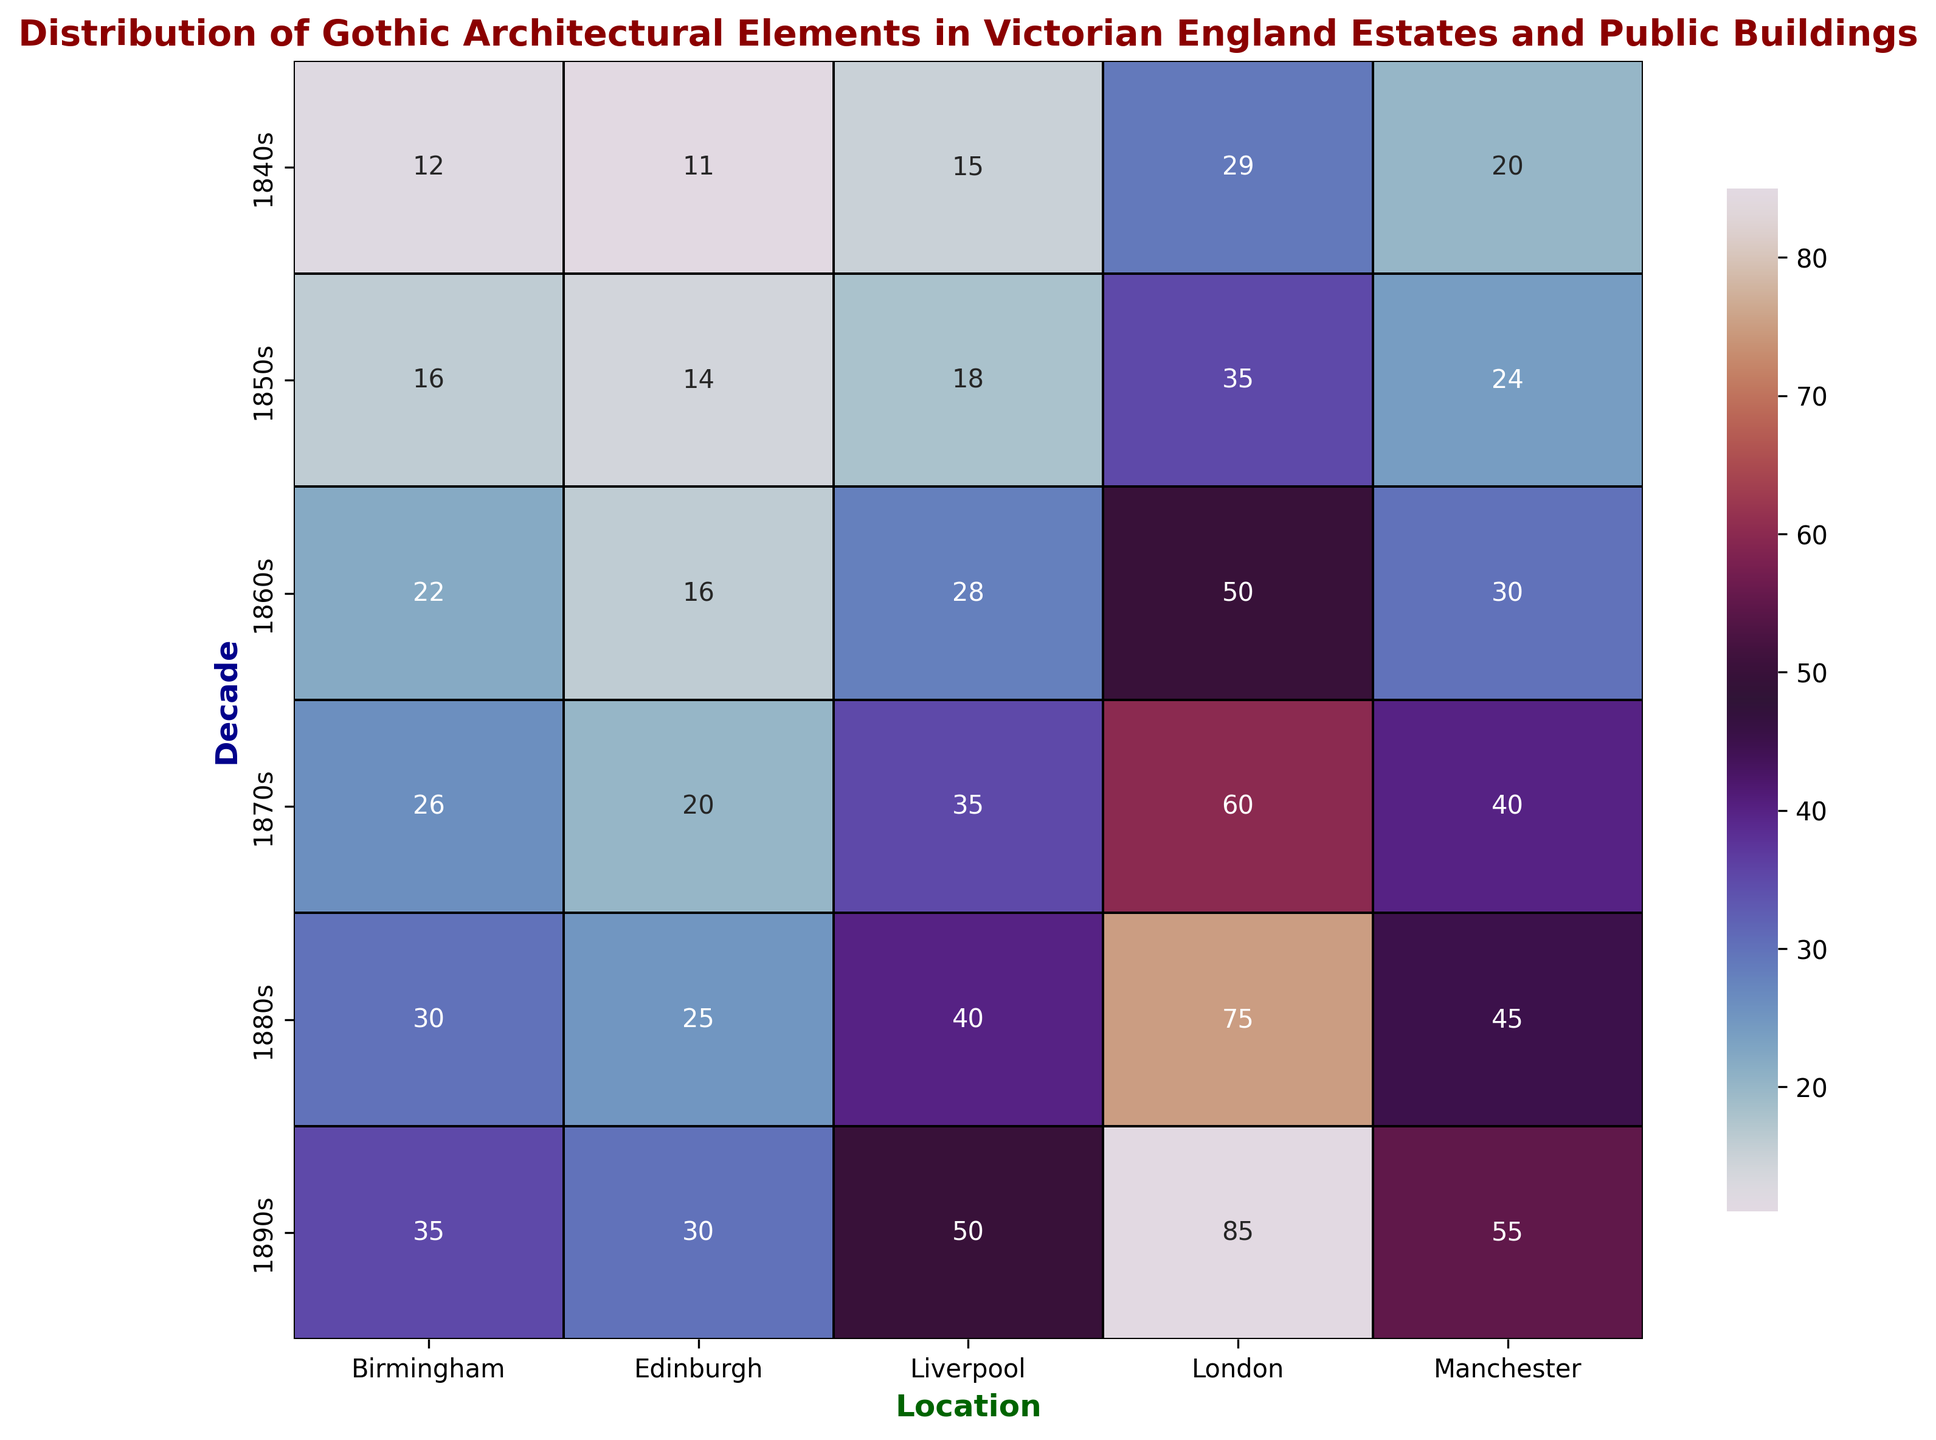What is the location with the highest number of Gothic architectural elements in the 1860s? To find the answer, look at the 1860s row and compare the numbers in each location column. London has the highest value in that decade with 50 elements.
Answer: London Which decade shows the greatest overall increase in Gothic architectural elements in London? Examine the figures for London across the decades. The increase is calculated by subtracting the previous decade's number from the current decade's number. The increase from the 1880s to the 1890s is the largest (85 - 75 = 10).
Answer: 1890s How many more Gothic architectural elements are there in Manchester compared to Edinburgh in the 1880s? Locate the numbers for Manchester and Edinburgh in the 1880s row. Subtract Edinburgh's number (25) from Manchester's number (45). 45 - 25 = 20.
Answer: 20 What is the average number of Gothic architectural elements in Birmingham across all decades? Add the values for Birmingham across all decades: 12 + 16 + 22 + 26 + 30 + 35 = 141. Divide by the number of decades (6). 141 / 6 = 23.5.
Answer: 23.5 Which location has the lowest number of Gothic architectural elements in the 1840s and how many are there? Look at the 1840s row and find the lowest value, which is 11 for Edinburgh.
Answer: Edinburgh, 11 How do the number of Gothic architectural elements in the 1850s in Liverpool compare to those in Edinburgh in the same decade? Locate the values for Liverpool (18) and Edinburgh (14) in the 1850s row. Liverpool has more elements.
Answer: Liverpool has more Which two locations have the same number of Gothic architectural elements in any decade? Locate identical values in the same row across the locations columns. In the 1840s, Manchester has 20, and no other location has the same value. Continue to the next row. In the 1850s, the values are unique to each location. Repeat this process until you find that in the 1850s, no two locations share the same number of elements. Proceed further with similar checks, here's the list: Edinburgh, no exact match across other localities with a total count.
Answer: No exact match What is the trend of Gothic architectural elements from the 1840s to the 1890s in London? Observe the values in the 'London' column between the 1840s and the 1890s (29, 35, 50, 60, 75, 85). There is an upward trend in the number of Gothic architectural elements over the decades.
Answer: Increasing trend If we sum the number of Gothic architectural elements in Liverpool for the 1860s and 1870s, what is the total? Add the values for Liverpool in the 1860s (28) and 1870s (35). 28 + 35 = 63.
Answer: 63 